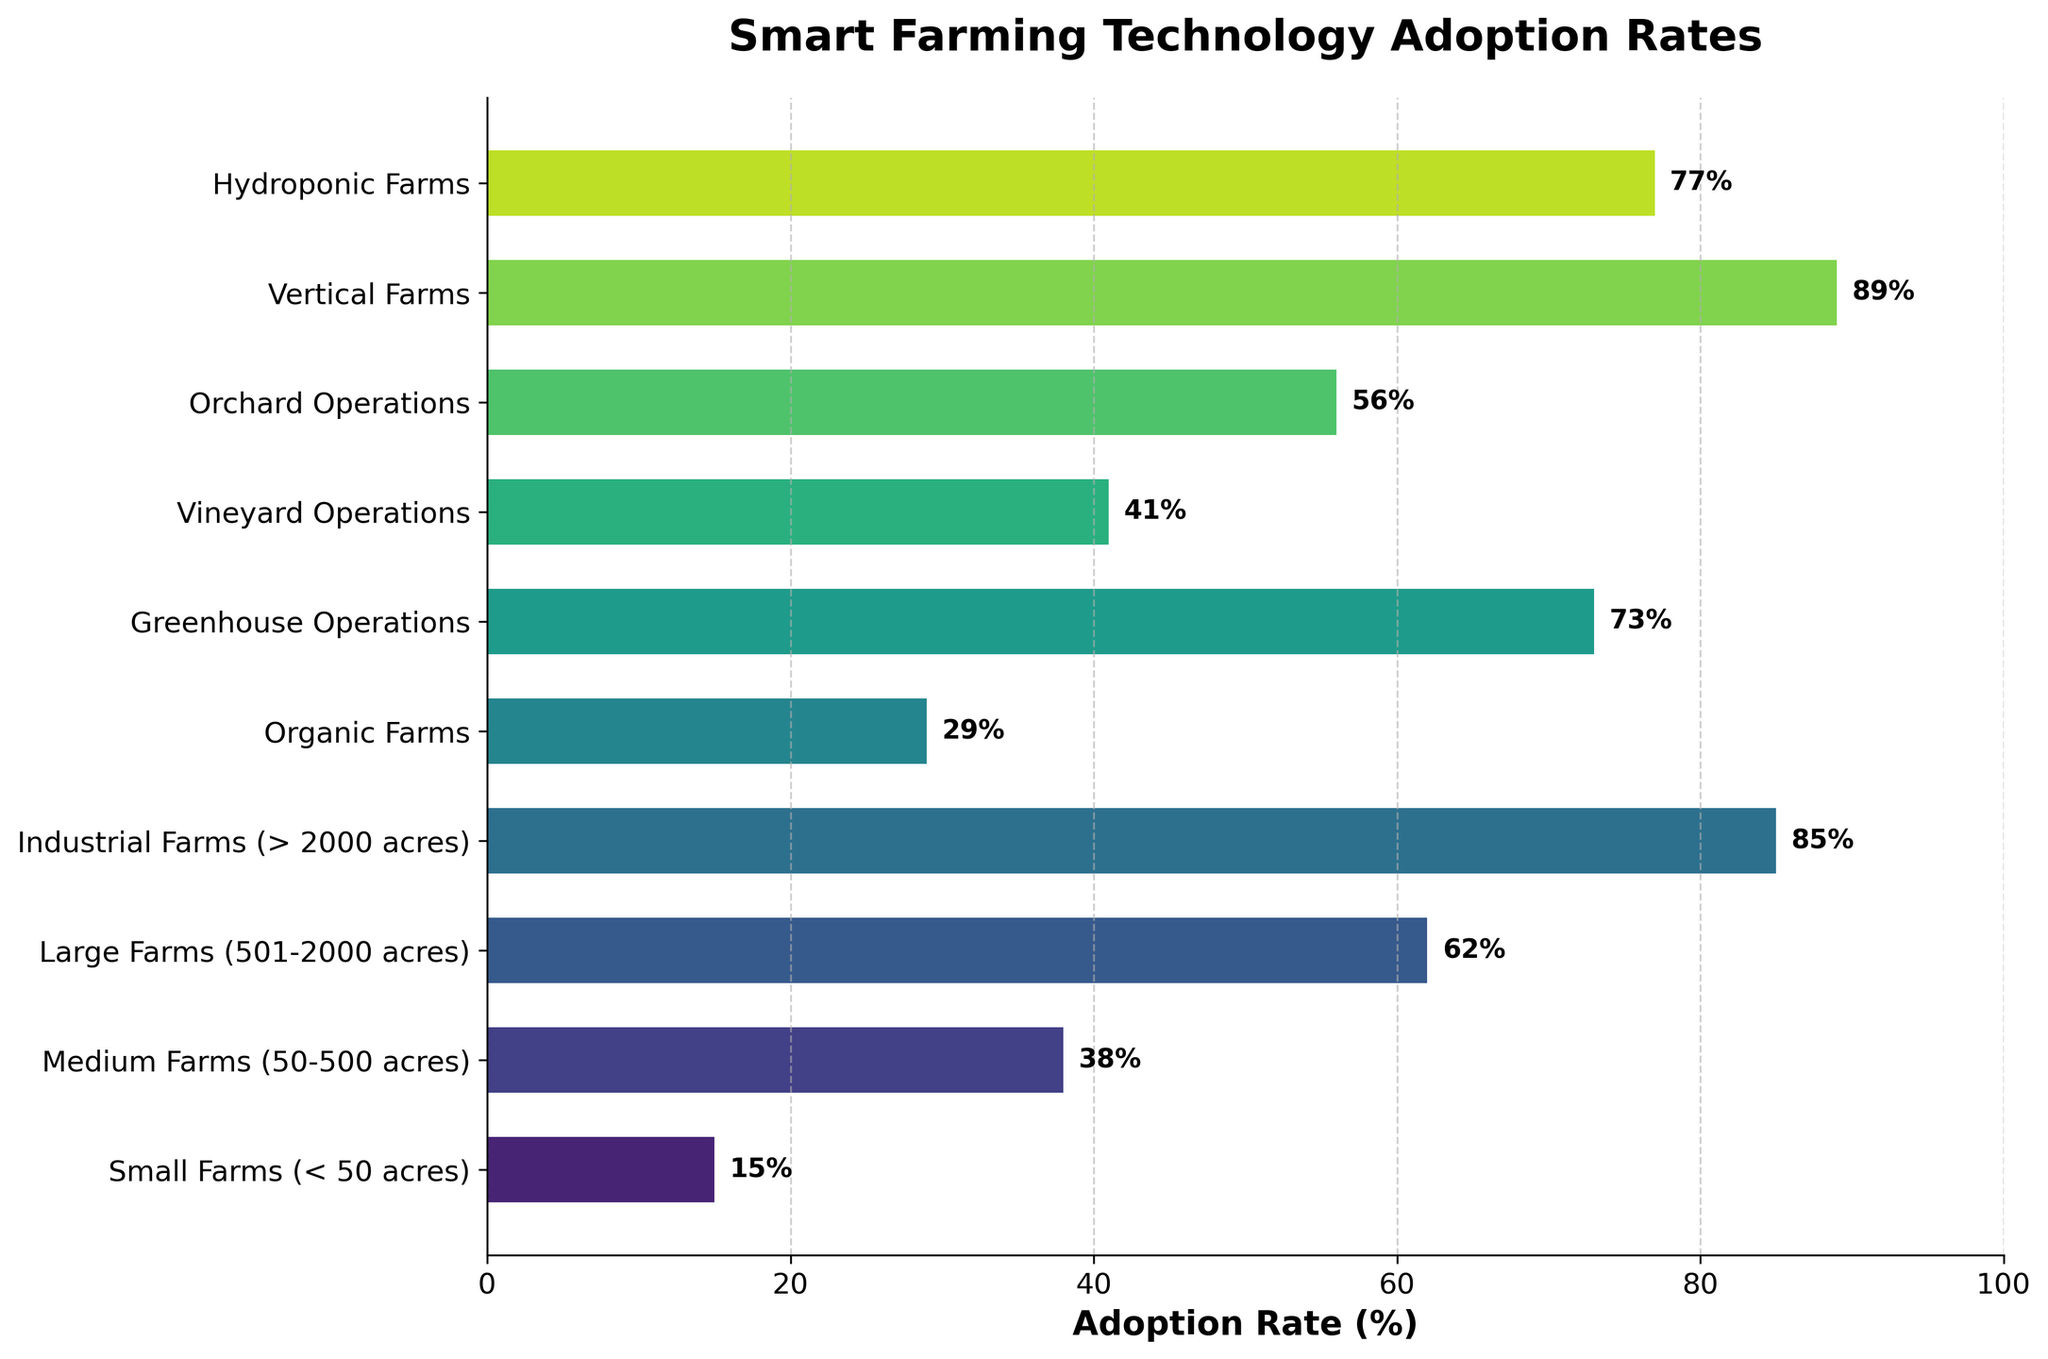Which farm type has the highest adoption rate of smart farming technologies? The figure shows bars representing adoption rates; the longest bar corresponds to the highest adoption. The Vertical Farms bar extends to 89%, the highest in the chart.
Answer: Vertical Farms Which farm type has the lowest adoption rate of smart farming technologies? The figure shows bars representing adoption rates; the shortest bar corresponds to the lowest adoption. The Small Farms bar extends to 15%, the lowest in the chart.
Answer: Small Farms What is the difference in adoption rates between Medium Farms and Greenhouse Operations? Medium Farms have an adoption rate of 38%, and Greenhouse Operations have an adoption rate of 73%. The difference is 73% - 38% = 35%.
Answer: 35% Which farm types have an adoption rate greater than 60%? The bars representing adoption rates greater than 60% are those of Large Farms (62%), Greenhouse Operations (73%), Vertical Farms (89%), and Hydroponic Farms (77%).
Answer: Large Farms, Greenhouse Operations, Vertical Farms, Hydroponic Farms Are there more farm types with adoption rates above or below 50%? Farm types with adoption rates above 50% are Large Farms, Greenhouse Operations, Vertical Farms, Hydroponic Farms, and Orchard Operations, totaling 5. Those below 50% are Small Farms, Medium Farms, Organic Farms, and Vineyard Operations, totaling 4.
Answer: Above What is the average adoption rate of smart farming technologies across all farm types? Sum the adoption rates (15 + 38 + 62 + 85 + 29 + 73 + 41 + 56 + 89 + 77) = 565. There are 10 farm types, so the average is 565 / 10 = 56.5%.
Answer: 56.5% Compare the adoption rates of Orchard Operations and Vineyard Operations. Which one is higher? By how much? Orchard Operations have an adoption rate of 56%, and Vineyard Operations have an adoption rate of 41%. The difference is 56% - 41% = 15%.
Answer: Orchard Operations, 15% What is the combined adoption rate of Industrial Farms and Hydroponic Farms? The adoption rate for Industrial Farms is 85%, and for Hydroponic Farms is 77%. The combined rate is 85% + 77% = 162%.
Answer: 162% Which farm type with an adoption rate less than 50% is closest to that threshold? The bars representing adoption rates less than 50% are Small Farms (15%), Medium Farms (38%), Organic Farms (29%), and Vineyard Operations (41%). The one closest to 50% is Vineyard Operations at 41%.
Answer: Vineyard Operations 